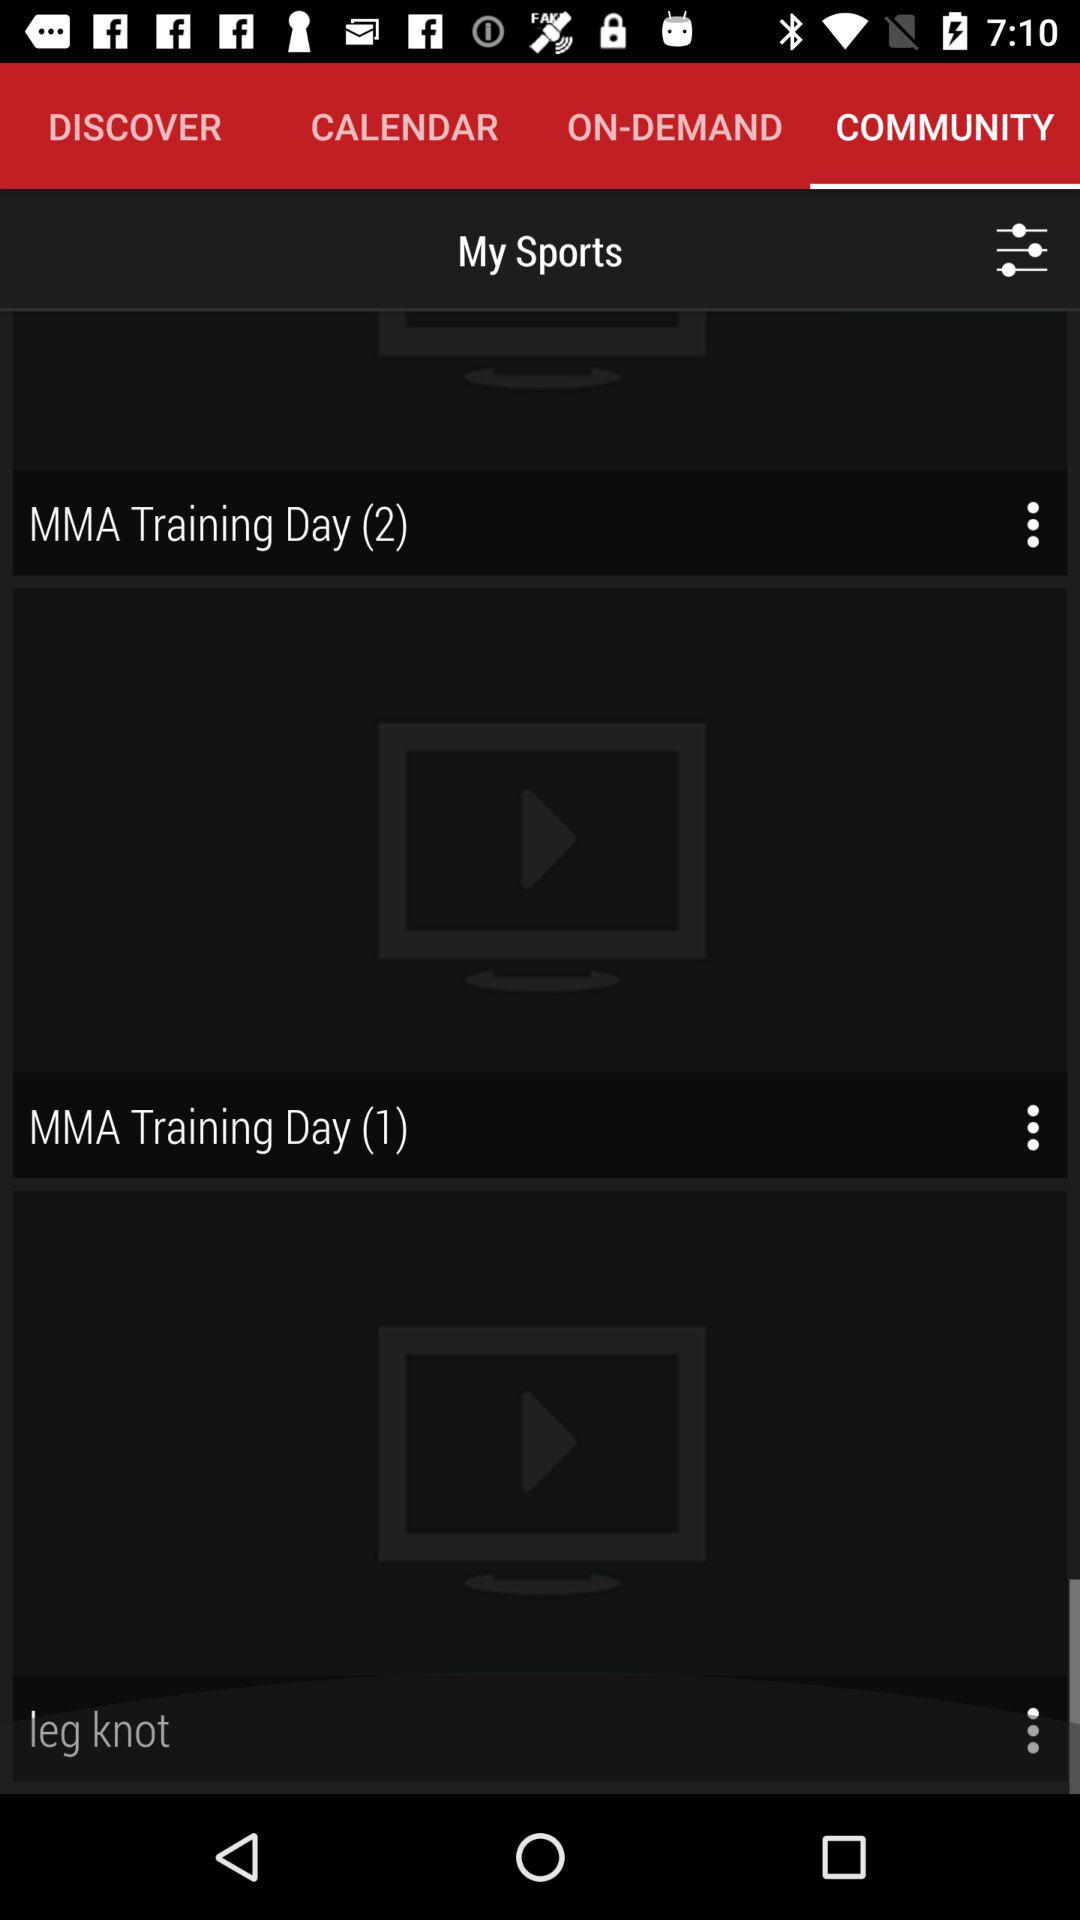What tab has been selected? The selected tab is "COMMUNITY". 